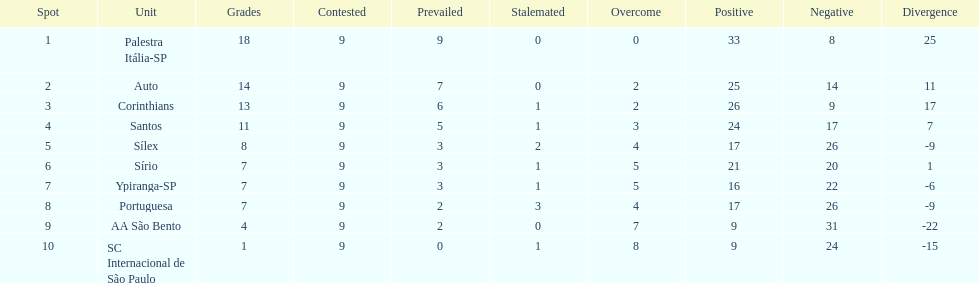In 1926 brazilian football, how many teams scored above 10 points in the season? 4. 